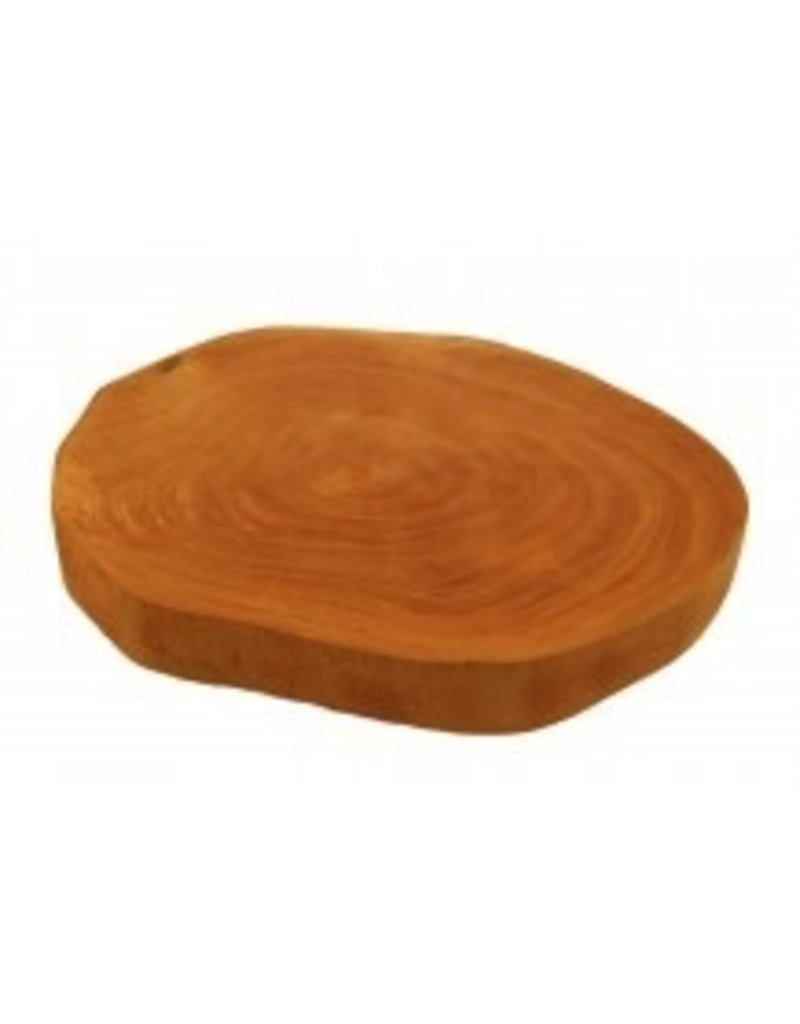What additional information can be inferred about the tree’s health or environmental changes from the patterns in the growth rings? The variation in ring thickness can suggest changes in the tree's health over time. For instance, a series of very thin rings might indicate a prolonged drought or other severe environmental stress. On the other hand, sudden increases in ring thickness could suggest a marked improvement in conditions, such as after the end of a drought or the implementation of conservation measures. Analyzing these patterns over time could provide valuable insights into historical environmental conditions and the tree's resilience. 